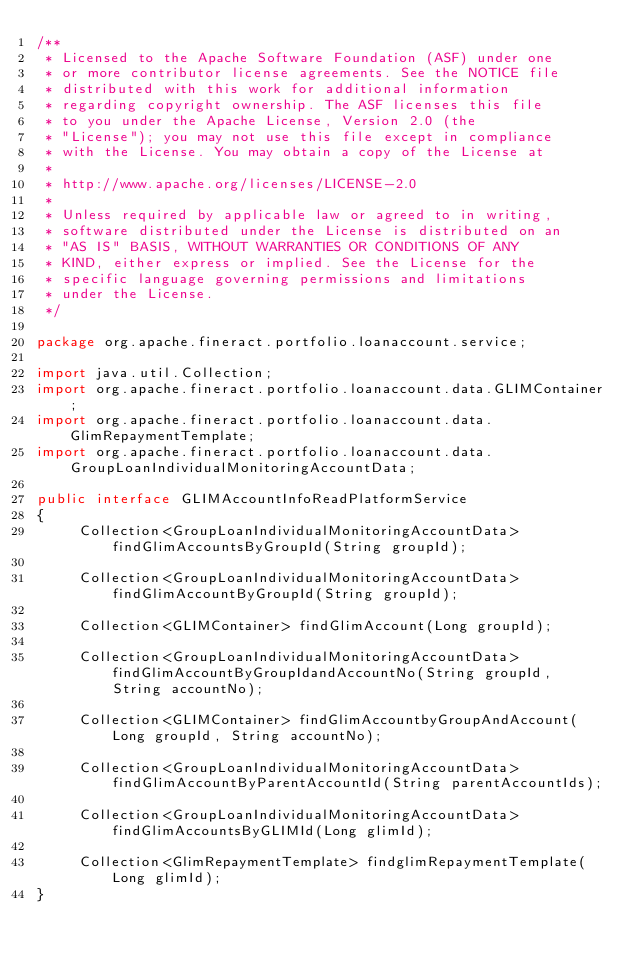<code> <loc_0><loc_0><loc_500><loc_500><_Java_>/**
 * Licensed to the Apache Software Foundation (ASF) under one
 * or more contributor license agreements. See the NOTICE file
 * distributed with this work for additional information
 * regarding copyright ownership. The ASF licenses this file
 * to you under the Apache License, Version 2.0 (the
 * "License"); you may not use this file except in compliance
 * with the License. You may obtain a copy of the License at
 *
 * http://www.apache.org/licenses/LICENSE-2.0
 *
 * Unless required by applicable law or agreed to in writing,
 * software distributed under the License is distributed on an
 * "AS IS" BASIS, WITHOUT WARRANTIES OR CONDITIONS OF ANY
 * KIND, either express or implied. See the License for the
 * specific language governing permissions and limitations
 * under the License.
 */

package org.apache.fineract.portfolio.loanaccount.service;

import java.util.Collection;
import org.apache.fineract.portfolio.loanaccount.data.GLIMContainer;
import org.apache.fineract.portfolio.loanaccount.data.GlimRepaymentTemplate;
import org.apache.fineract.portfolio.loanaccount.data.GroupLoanIndividualMonitoringAccountData;

public interface GLIMAccountInfoReadPlatformService
{
     Collection<GroupLoanIndividualMonitoringAccountData> findGlimAccountsByGroupId(String groupId);

     Collection<GroupLoanIndividualMonitoringAccountData> findGlimAccountByGroupId(String groupId);

     Collection<GLIMContainer> findGlimAccount(Long groupId);

     Collection<GroupLoanIndividualMonitoringAccountData> findGlimAccountByGroupIdandAccountNo(String groupId, String accountNo);

     Collection<GLIMContainer> findGlimAccountbyGroupAndAccount(Long groupId, String accountNo);

     Collection<GroupLoanIndividualMonitoringAccountData> findGlimAccountByParentAccountId(String parentAccountIds);

     Collection<GroupLoanIndividualMonitoringAccountData> findGlimAccountsByGLIMId(Long glimId);

     Collection<GlimRepaymentTemplate> findglimRepaymentTemplate(Long glimId);
}</code> 